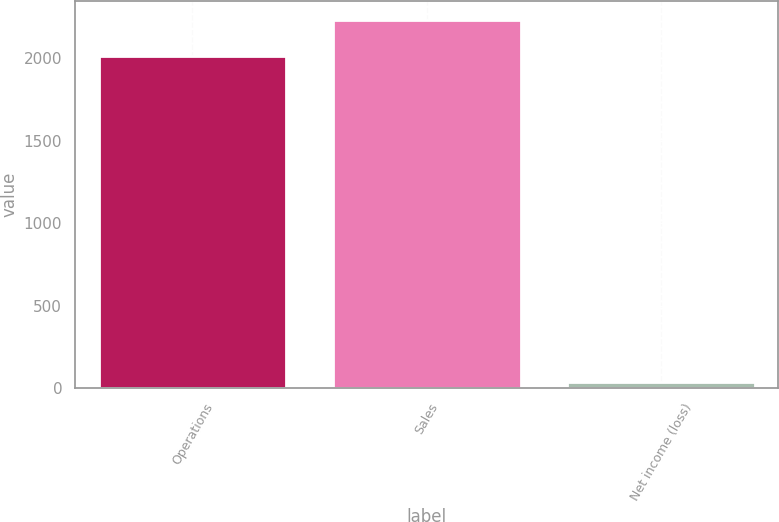Convert chart. <chart><loc_0><loc_0><loc_500><loc_500><bar_chart><fcel>Operations<fcel>Sales<fcel>Net income (loss)<nl><fcel>2011<fcel>2233<fcel>34<nl></chart> 